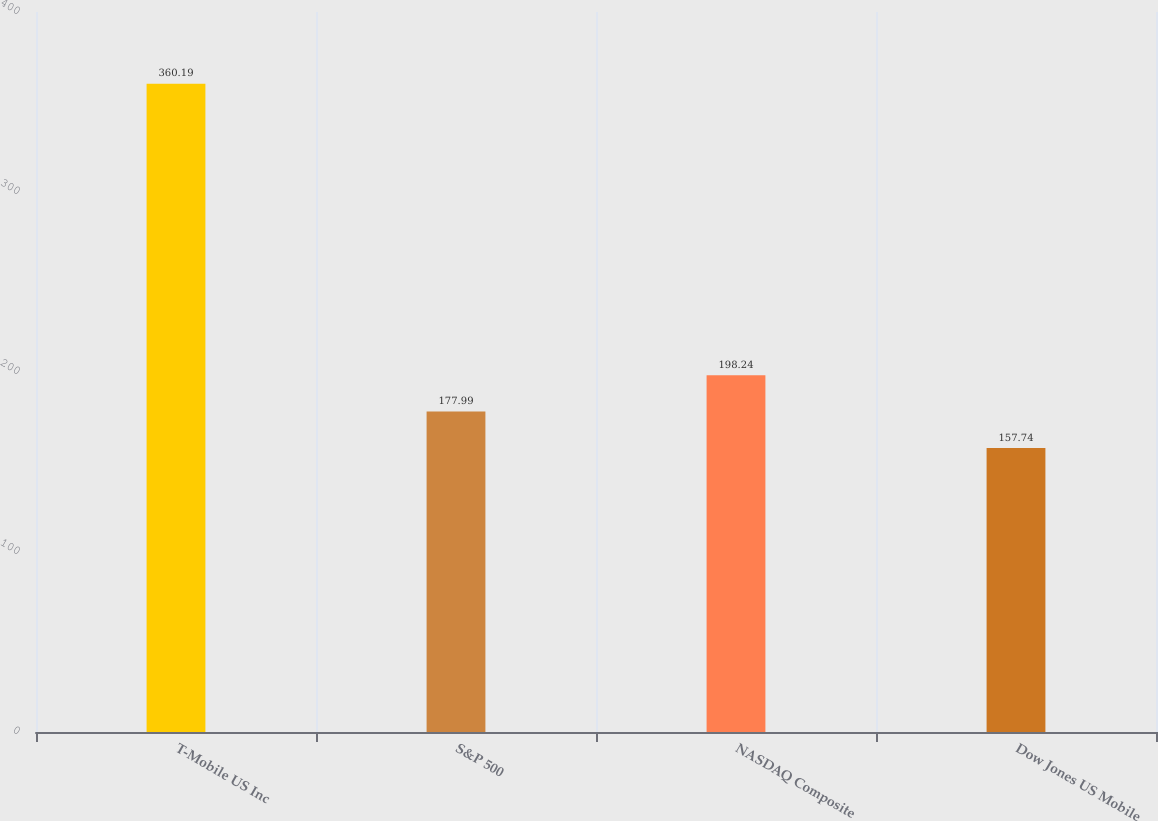<chart> <loc_0><loc_0><loc_500><loc_500><bar_chart><fcel>T-Mobile US Inc<fcel>S&P 500<fcel>NASDAQ Composite<fcel>Dow Jones US Mobile<nl><fcel>360.19<fcel>177.99<fcel>198.24<fcel>157.74<nl></chart> 